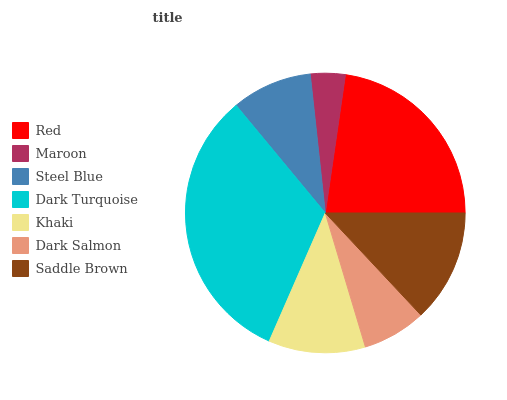Is Maroon the minimum?
Answer yes or no. Yes. Is Dark Turquoise the maximum?
Answer yes or no. Yes. Is Steel Blue the minimum?
Answer yes or no. No. Is Steel Blue the maximum?
Answer yes or no. No. Is Steel Blue greater than Maroon?
Answer yes or no. Yes. Is Maroon less than Steel Blue?
Answer yes or no. Yes. Is Maroon greater than Steel Blue?
Answer yes or no. No. Is Steel Blue less than Maroon?
Answer yes or no. No. Is Khaki the high median?
Answer yes or no. Yes. Is Khaki the low median?
Answer yes or no. Yes. Is Saddle Brown the high median?
Answer yes or no. No. Is Steel Blue the low median?
Answer yes or no. No. 